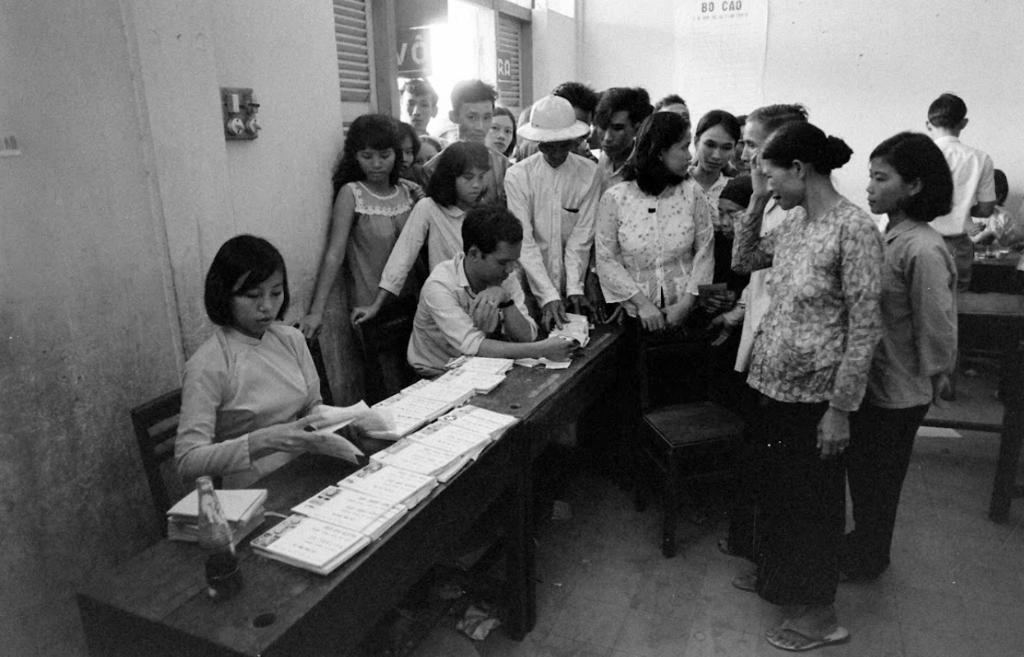Could you give a brief overview of what you see in this image? In this image I can see number of people where everyone is standing and few of them are sitting. I can also see few papers on this table. 